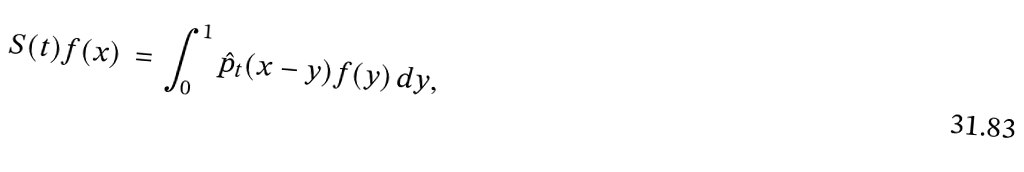<formula> <loc_0><loc_0><loc_500><loc_500>S ( t ) f ( x ) \, = \, \int _ { 0 } ^ { 1 } \hat { p } _ { t } ( x - y ) f ( y ) \, d y ,</formula> 